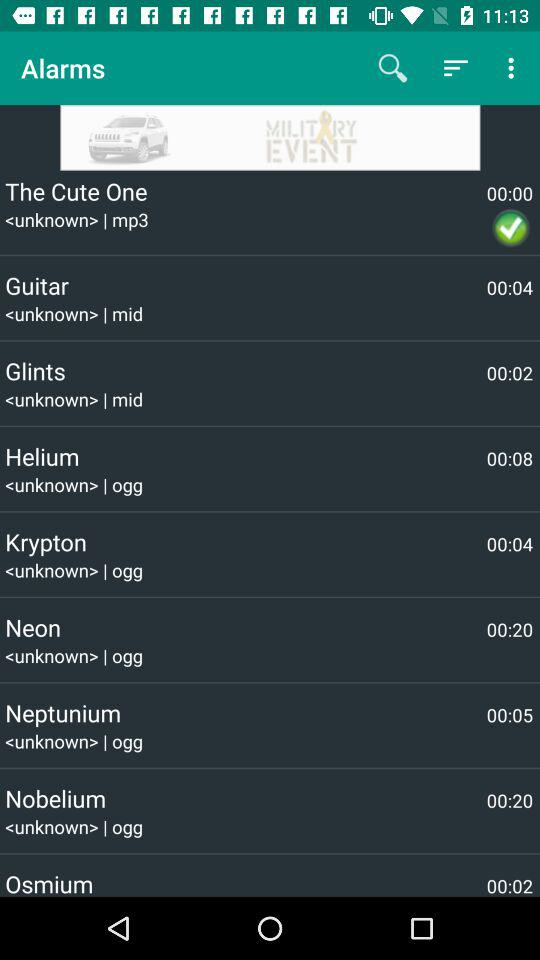Which is the selected alarm? The selected alarm is "The Cute One". 